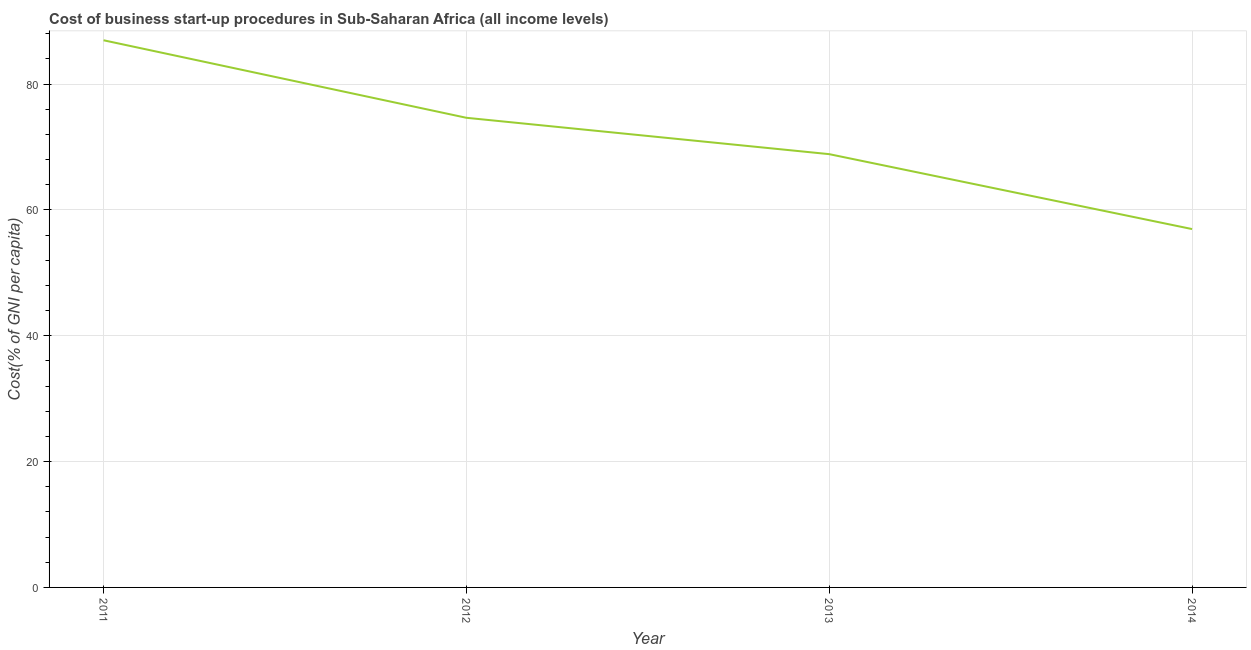What is the cost of business startup procedures in 2013?
Provide a short and direct response. 68.86. Across all years, what is the maximum cost of business startup procedures?
Offer a very short reply. 86.96. Across all years, what is the minimum cost of business startup procedures?
Make the answer very short. 56.95. What is the sum of the cost of business startup procedures?
Offer a very short reply. 287.41. What is the difference between the cost of business startup procedures in 2013 and 2014?
Provide a succinct answer. 11.9. What is the average cost of business startup procedures per year?
Keep it short and to the point. 71.85. What is the median cost of business startup procedures?
Make the answer very short. 71.75. In how many years, is the cost of business startup procedures greater than 52 %?
Offer a very short reply. 4. Do a majority of the years between 2012 and 2014 (inclusive) have cost of business startup procedures greater than 28 %?
Your answer should be very brief. Yes. What is the ratio of the cost of business startup procedures in 2011 to that in 2012?
Your answer should be compact. 1.17. Is the difference between the cost of business startup procedures in 2011 and 2013 greater than the difference between any two years?
Your response must be concise. No. What is the difference between the highest and the second highest cost of business startup procedures?
Provide a succinct answer. 12.32. Is the sum of the cost of business startup procedures in 2011 and 2013 greater than the maximum cost of business startup procedures across all years?
Offer a very short reply. Yes. What is the difference between the highest and the lowest cost of business startup procedures?
Your response must be concise. 30. How many lines are there?
Provide a succinct answer. 1. What is the difference between two consecutive major ticks on the Y-axis?
Ensure brevity in your answer.  20. Does the graph contain grids?
Make the answer very short. Yes. What is the title of the graph?
Offer a terse response. Cost of business start-up procedures in Sub-Saharan Africa (all income levels). What is the label or title of the X-axis?
Offer a terse response. Year. What is the label or title of the Y-axis?
Offer a terse response. Cost(% of GNI per capita). What is the Cost(% of GNI per capita) in 2011?
Give a very brief answer. 86.96. What is the Cost(% of GNI per capita) of 2012?
Provide a short and direct response. 74.64. What is the Cost(% of GNI per capita) of 2013?
Provide a short and direct response. 68.86. What is the Cost(% of GNI per capita) of 2014?
Provide a short and direct response. 56.95. What is the difference between the Cost(% of GNI per capita) in 2011 and 2012?
Ensure brevity in your answer.  12.32. What is the difference between the Cost(% of GNI per capita) in 2011 and 2013?
Offer a very short reply. 18.1. What is the difference between the Cost(% of GNI per capita) in 2011 and 2014?
Ensure brevity in your answer.  30. What is the difference between the Cost(% of GNI per capita) in 2012 and 2013?
Give a very brief answer. 5.78. What is the difference between the Cost(% of GNI per capita) in 2012 and 2014?
Your answer should be very brief. 17.68. What is the difference between the Cost(% of GNI per capita) in 2013 and 2014?
Your answer should be very brief. 11.9. What is the ratio of the Cost(% of GNI per capita) in 2011 to that in 2012?
Provide a succinct answer. 1.17. What is the ratio of the Cost(% of GNI per capita) in 2011 to that in 2013?
Your answer should be very brief. 1.26. What is the ratio of the Cost(% of GNI per capita) in 2011 to that in 2014?
Ensure brevity in your answer.  1.53. What is the ratio of the Cost(% of GNI per capita) in 2012 to that in 2013?
Offer a very short reply. 1.08. What is the ratio of the Cost(% of GNI per capita) in 2012 to that in 2014?
Offer a very short reply. 1.31. What is the ratio of the Cost(% of GNI per capita) in 2013 to that in 2014?
Make the answer very short. 1.21. 